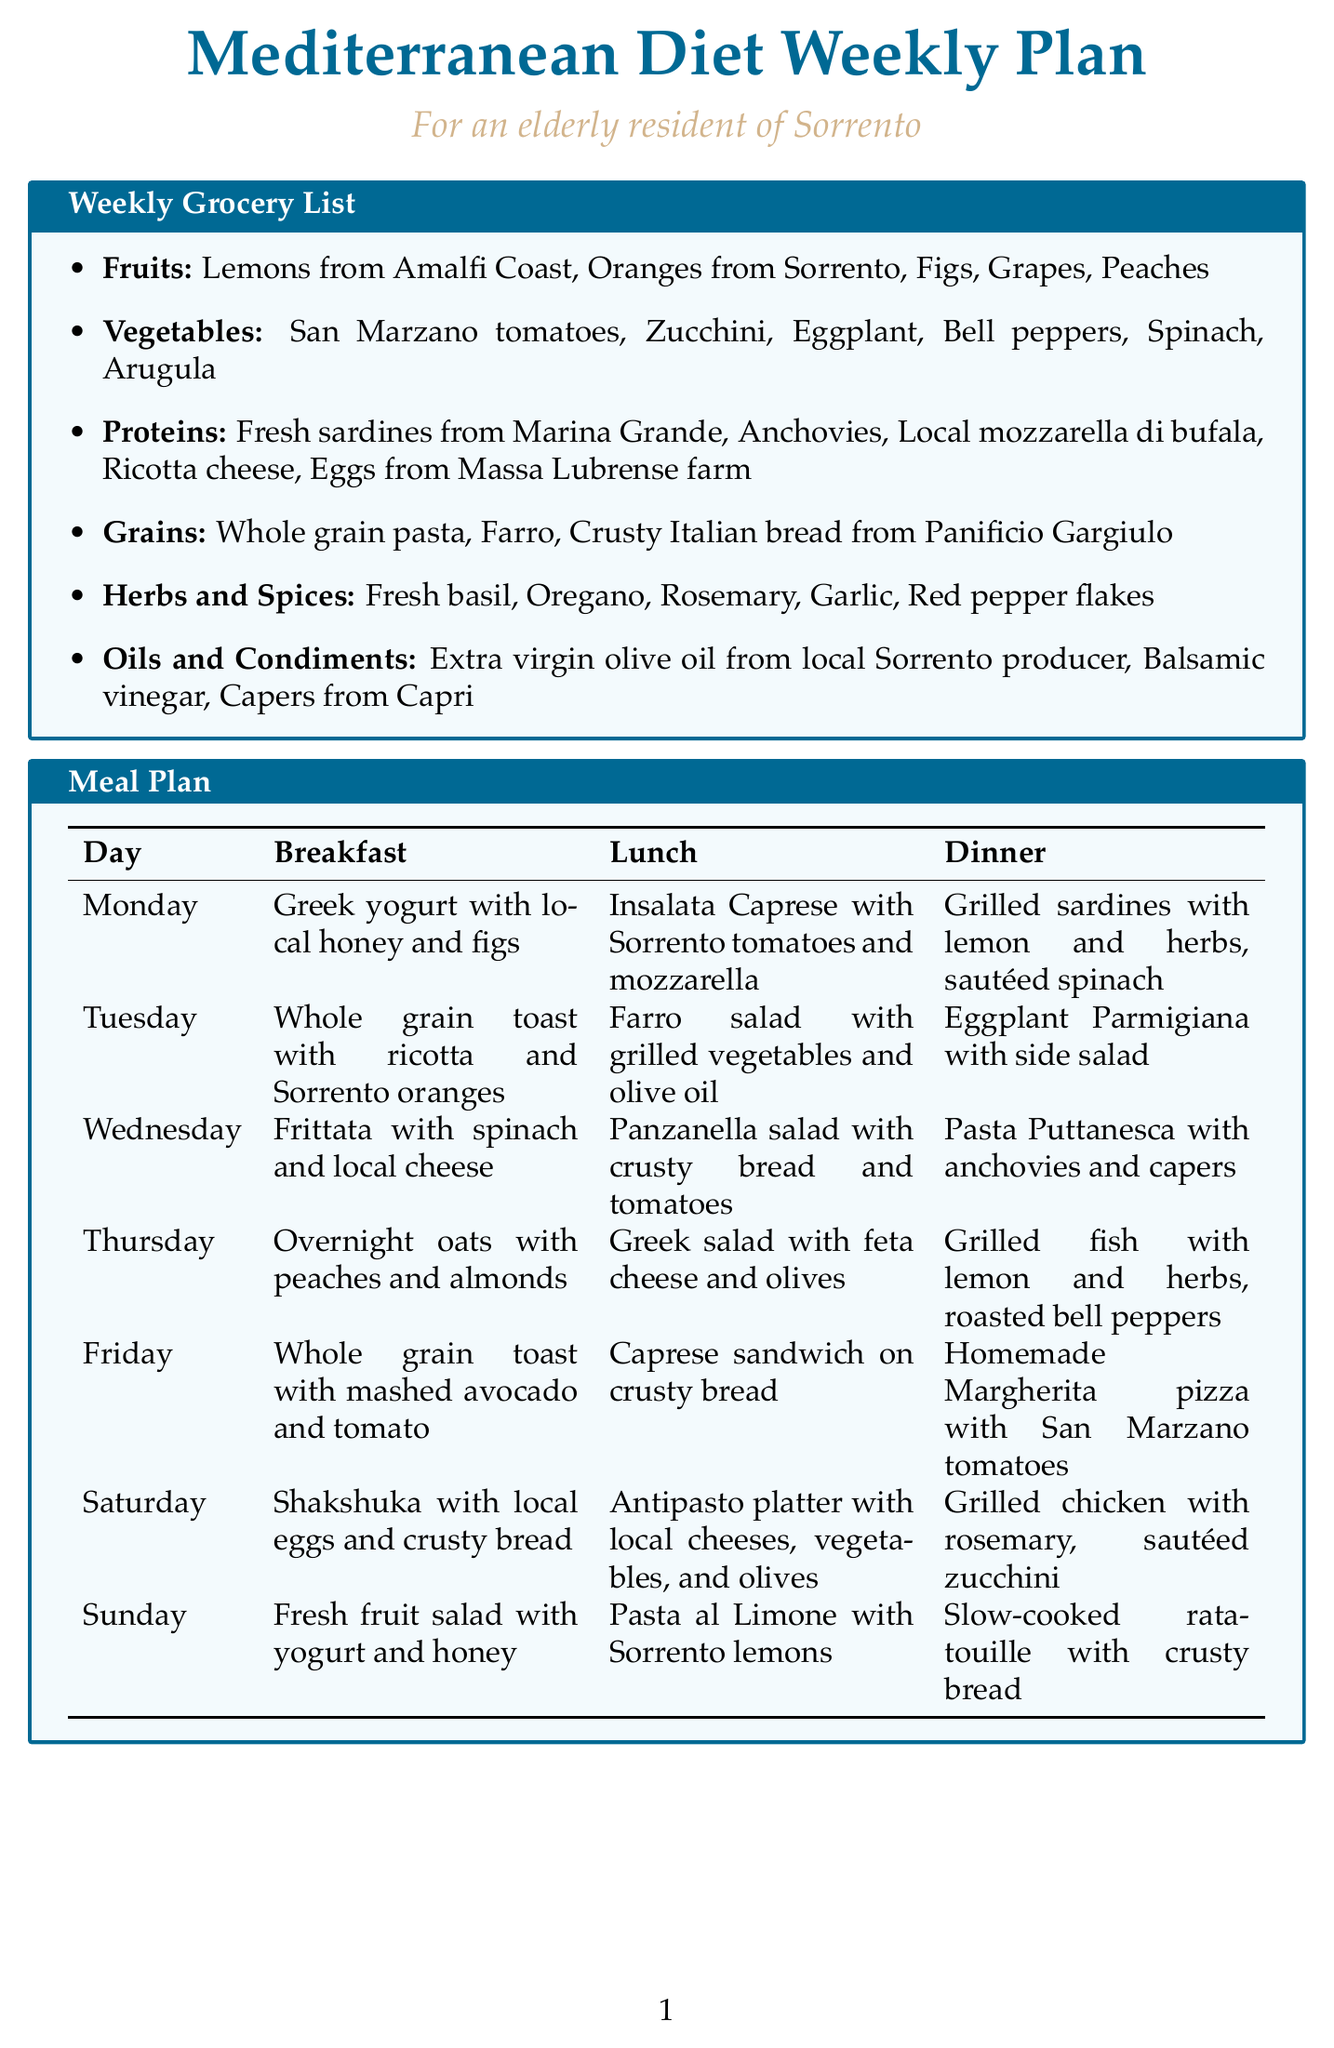what fruits are listed in the grocery list? The fruits included in the grocery list are mentioned clearly under the Fruits category.
Answer: Lemons from Amalfi Coast, Oranges from Sorrento, Figs, Grapes, Peaches which day features Shakshuka for breakfast? Referring to the meal plan section, Shakshuka is indicated for Saturday's breakfast.
Answer: Saturday where can I find fresh fish in Sorrento? The document includes a local market section that specifies where to buy fresh fish.
Answer: Pescheria Da Michele what is the main protein source highlighted in the meal plan? The proteins listed in the grocery list provide key sources of protein featured in the weekly plan.
Answer: Fresh sardines from Marina Grande what ingredient is used in the Greek salad? The meal plan describes specific ingredients for the Greek salad on Thursday.
Answer: Feta cheese how many days have a vegetarian dinner option? By analyzing the meal plan, we can see which dinners do not include meat.
Answer: Five days what is recommended to drizzle on dishes for maximum flavor? The cooking tips section gives a specific recommendation for enhancing flavors.
Answer: Extra virgin olive oil which local market specializes in cured meats? The local markets section provides details about market specialties, including cured meats.
Answer: Salumeria Ciro 